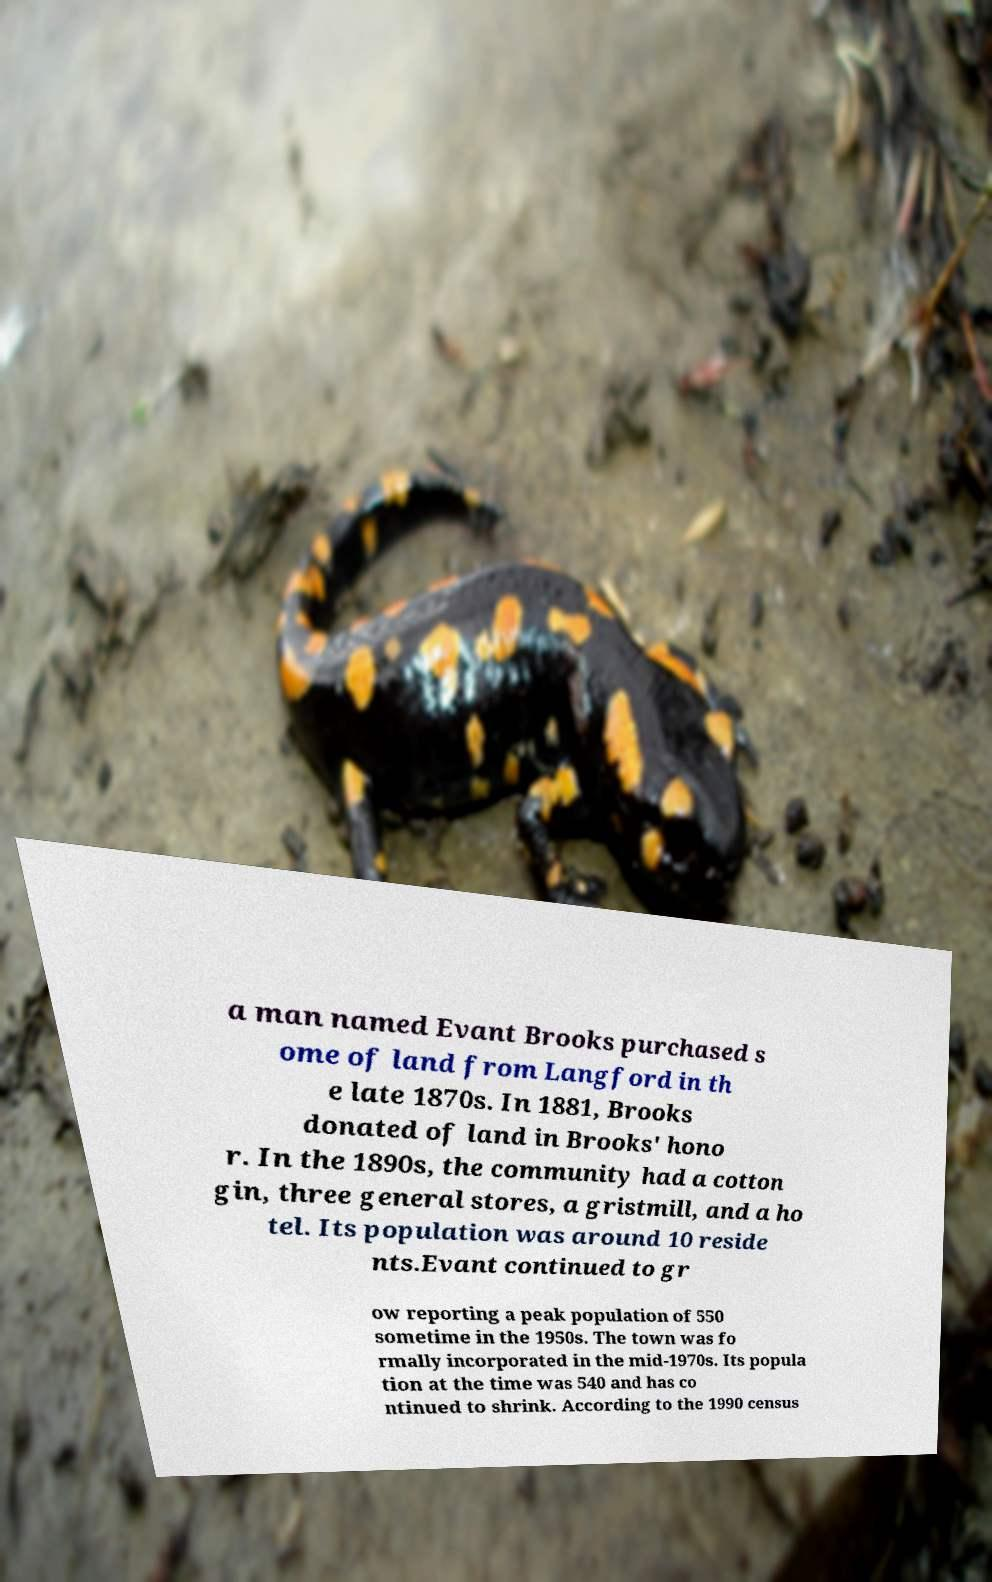I need the written content from this picture converted into text. Can you do that? a man named Evant Brooks purchased s ome of land from Langford in th e late 1870s. In 1881, Brooks donated of land in Brooks' hono r. In the 1890s, the community had a cotton gin, three general stores, a gristmill, and a ho tel. Its population was around 10 reside nts.Evant continued to gr ow reporting a peak population of 550 sometime in the 1950s. The town was fo rmally incorporated in the mid-1970s. Its popula tion at the time was 540 and has co ntinued to shrink. According to the 1990 census 